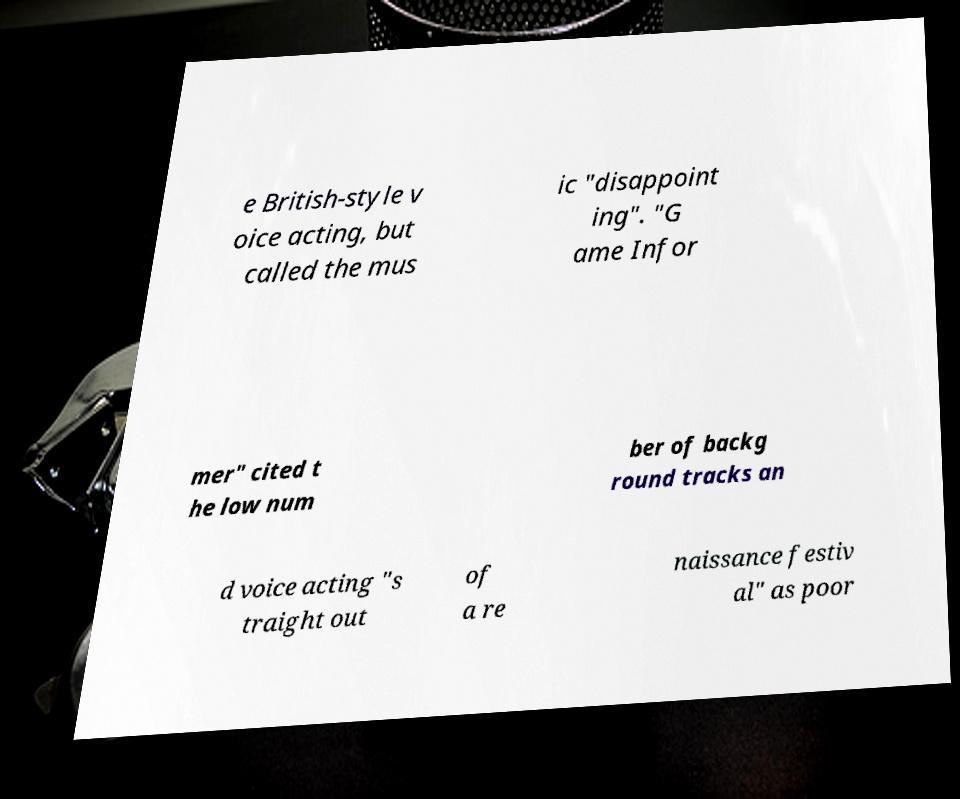Can you accurately transcribe the text from the provided image for me? e British-style v oice acting, but called the mus ic "disappoint ing". "G ame Infor mer" cited t he low num ber of backg round tracks an d voice acting "s traight out of a re naissance festiv al" as poor 